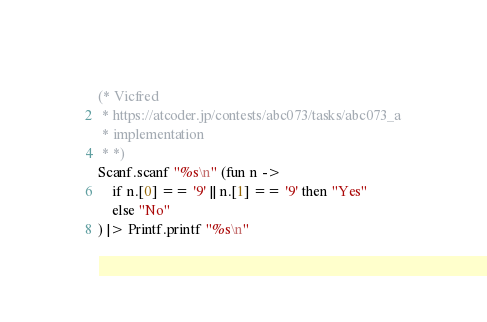<code> <loc_0><loc_0><loc_500><loc_500><_OCaml_>(* Vicfred
 * https://atcoder.jp/contests/abc073/tasks/abc073_a
 * implementation
 * *)
Scanf.scanf "%s\n" (fun n ->
    if n.[0] == '9' || n.[1] == '9' then "Yes"
    else "No"
) |> Printf.printf "%s\n"

</code> 